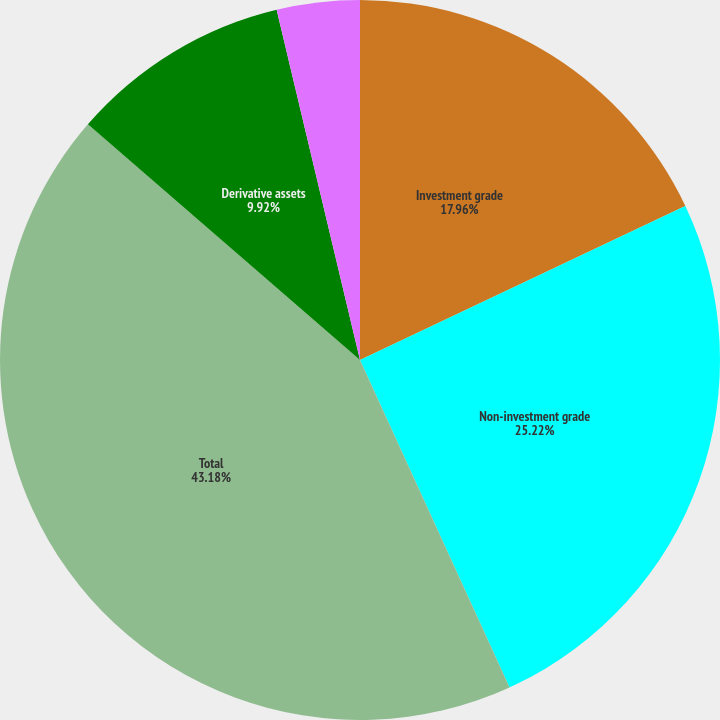Convert chart. <chart><loc_0><loc_0><loc_500><loc_500><pie_chart><fcel>Investment grade<fcel>Non-investment grade<fcel>Total<fcel>Derivative assets<fcel>Derivative liabilities<nl><fcel>17.96%<fcel>25.22%<fcel>43.18%<fcel>9.92%<fcel>3.72%<nl></chart> 